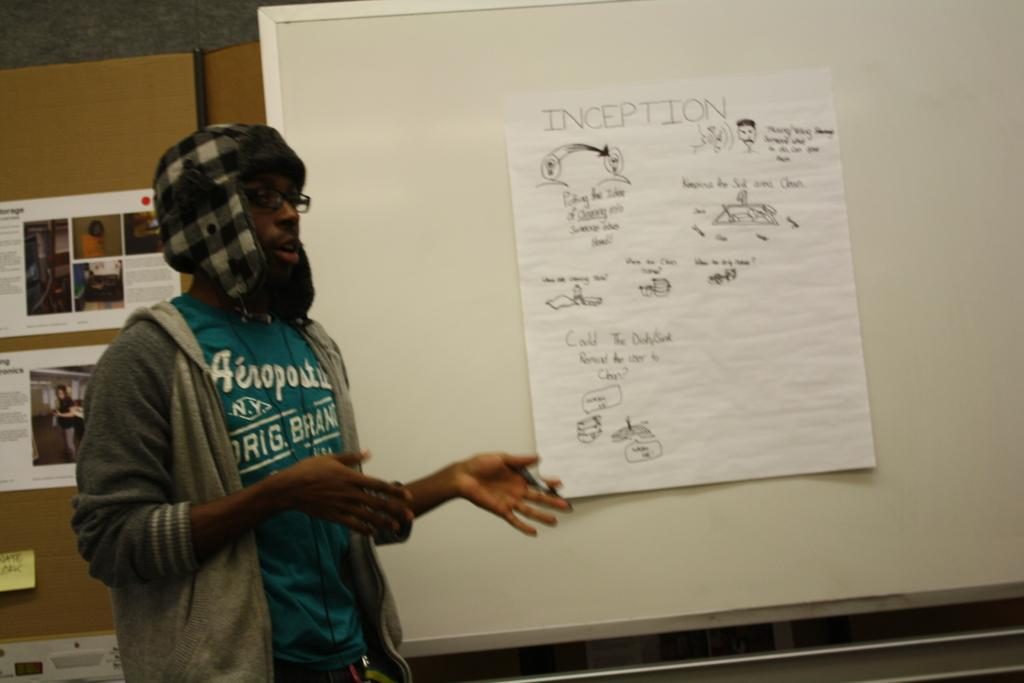<image>
Share a concise interpretation of the image provided. A piece of paper on a white board has the word inception at the top. 